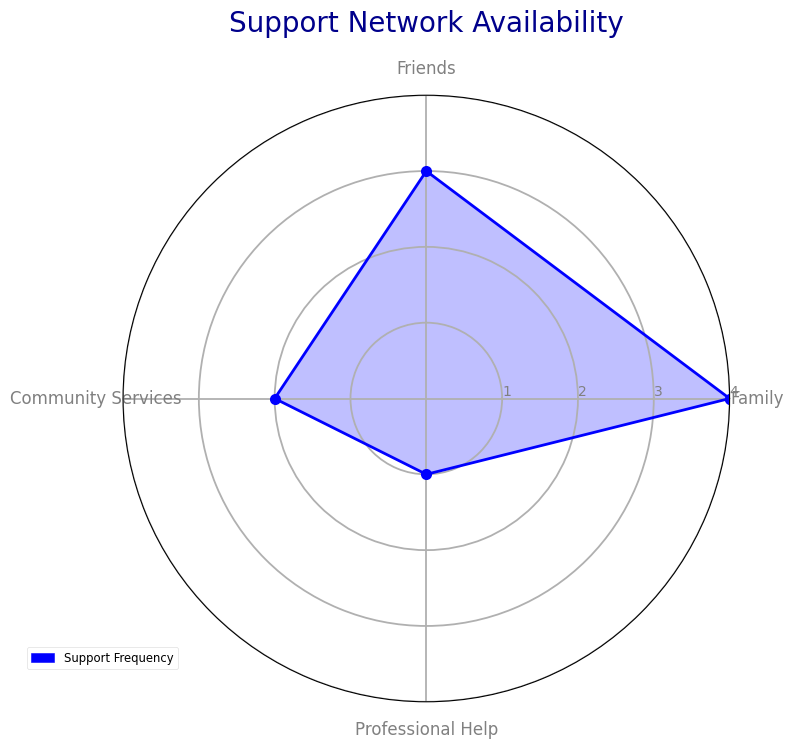Which category has the highest support frequency? The radar chart shows the frequency levels of support from different sources. By looking at the values plotted, the "Family" category has the highest point on the radar chart.
Answer: Family What is the total frequency of support from all categories combined? To find the total, sum up the frequencies of support from each category. From the chart: Family (4) + Friends (3) + Community Services (2) + Professional Help (1) = 10.
Answer: 10 Is the support frequency from Friends greater than the support frequency from Community Services? By comparing the values on the radar chart, the support frequency from Friends is 3, and from Community Services is 2. 3 is greater than 2.
Answer: Yes Which category has the lowest support frequency? The radar chart shows the frequency levels; the lowest point on the plot corresponds to "Professional Help," which has a frequency of 1.
Answer: Professional Help What is the average support frequency across all the categories? To find the average, sum the frequencies from all categories and divide by the number of categories. (4 + 3 + 2 + 1)/4 = 2.5.
Answer: 2.5 How much greater is the support frequency from Family compared to Professional Help? The support frequency for Family is 4, and for Professional Help is 1. The difference is 4 - 1 = 3.
Answer: 3 What is the difference in support frequencies between Friends and Community Services? The chart shows that Friends have a support frequency of 3, and Community Services have a support frequency of 2. The difference is 3 - 2 = 1.
Answer: 1 What is the composite score if we double the frequency of support from Community Services and add it to the total of all other frequencies? If the frequency from Community Services is doubled, it becomes 4. Adding it to the total of the other frequencies: 4 (Family) + 3 (Friends) + 4 (Doubled Community Services) + 1 (Professional Help) = 12.
Answer: 12 Does the support frequency from Friends and Community Services combined equal the support frequency from Family alone? The combined support frequency of Friends (3) and Community Services (2) is 3 + 2 = 5, while the support frequency from Family is 4. 5 is not equal to 4.
Answer: No What’s the range of the support frequencies in the radar chart? The range is found by subtracting the smallest value from the largest value. The largest frequency is 4 (Family) and the smallest is 1 (Professional Help). The range is 4 - 1 = 3.
Answer: 3 